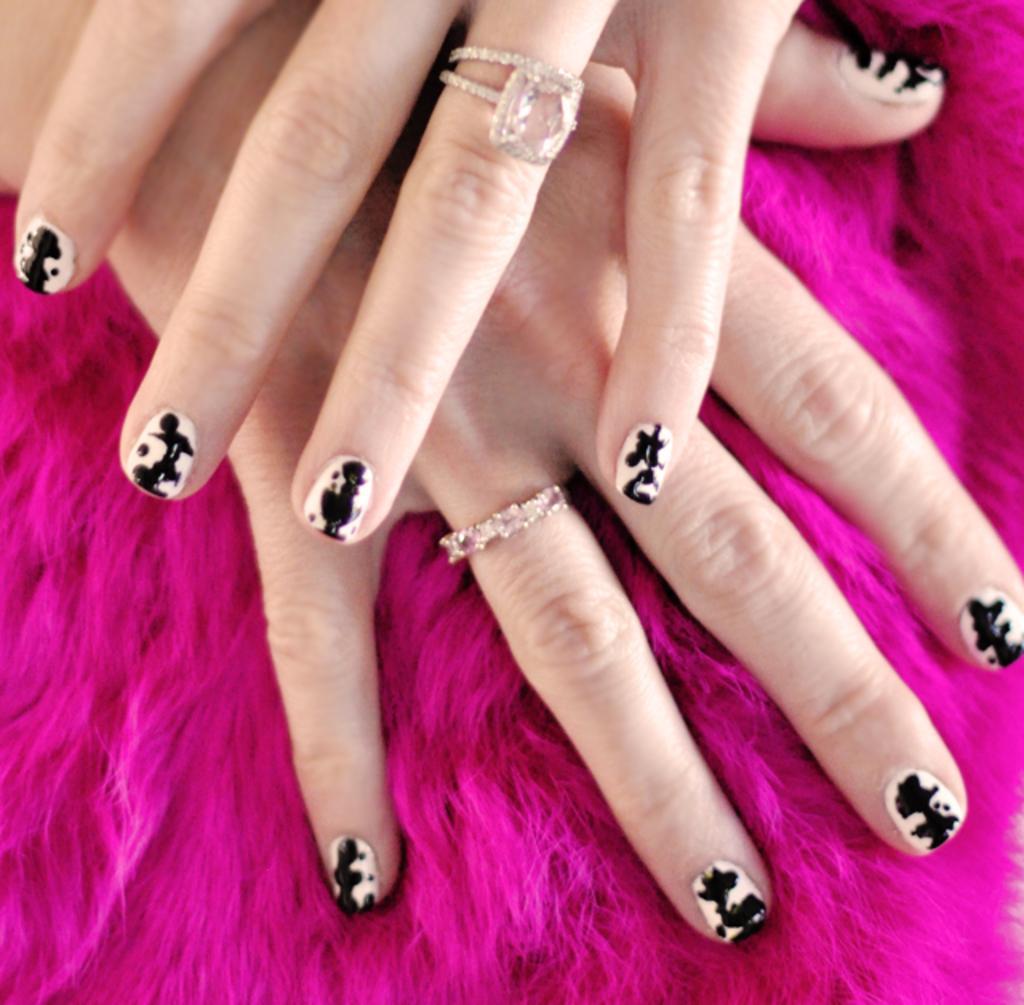How would you summarize this image in a sentence or two? In the picture we can see two women hands one on the other they are on the pink color fur surface and to the fingers we can see finger rings. 